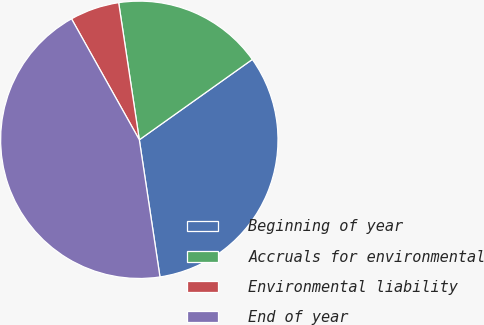<chart> <loc_0><loc_0><loc_500><loc_500><pie_chart><fcel>Beginning of year<fcel>Accruals for environmental<fcel>Environmental liability<fcel>End of year<nl><fcel>32.46%<fcel>17.54%<fcel>5.75%<fcel>44.25%<nl></chart> 